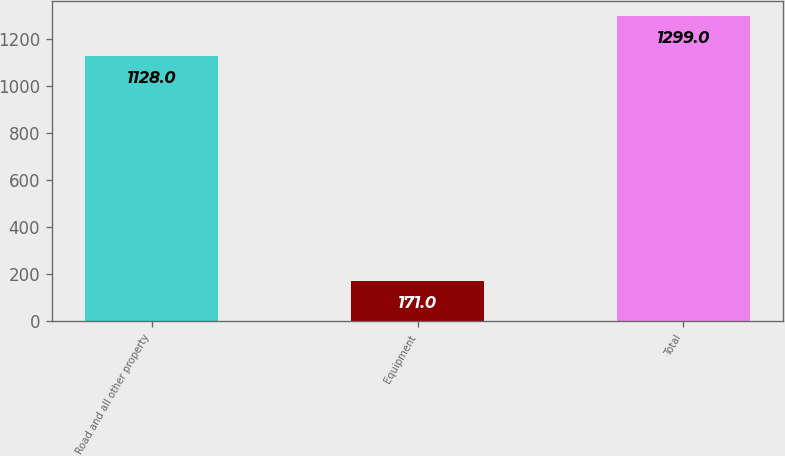Convert chart. <chart><loc_0><loc_0><loc_500><loc_500><bar_chart><fcel>Road and all other property<fcel>Equipment<fcel>Total<nl><fcel>1128<fcel>171<fcel>1299<nl></chart> 